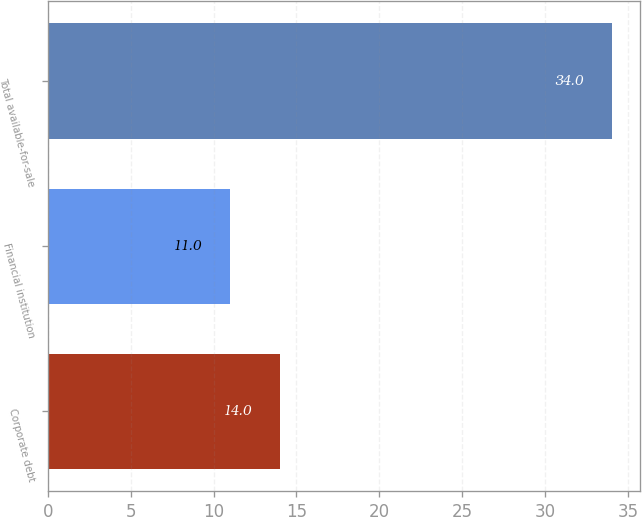Convert chart to OTSL. <chart><loc_0><loc_0><loc_500><loc_500><bar_chart><fcel>Corporate debt<fcel>Financial institution<fcel>Total available-for-sale<nl><fcel>14<fcel>11<fcel>34<nl></chart> 